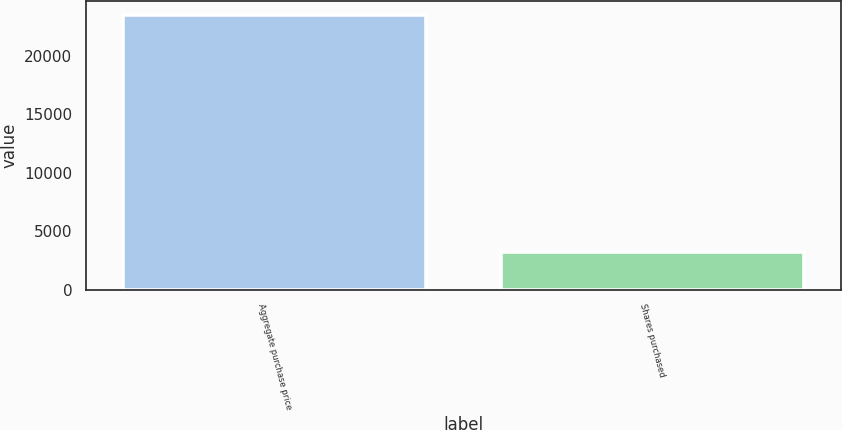Convert chart. <chart><loc_0><loc_0><loc_500><loc_500><bar_chart><fcel>Aggregate purchase price<fcel>Shares purchased<nl><fcel>23488<fcel>3177<nl></chart> 